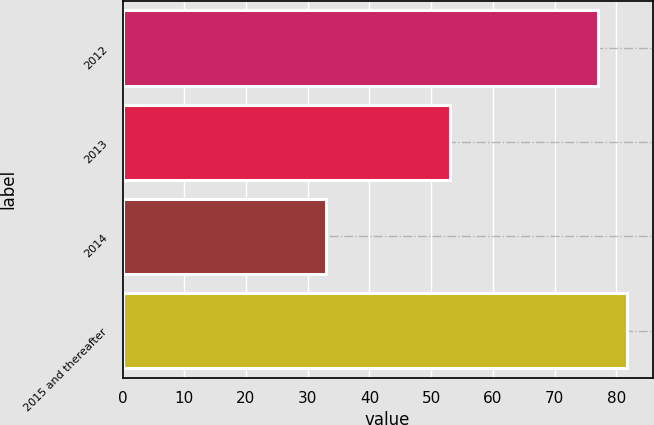Convert chart. <chart><loc_0><loc_0><loc_500><loc_500><bar_chart><fcel>2012<fcel>2013<fcel>2014<fcel>2015 and thereafter<nl><fcel>77<fcel>53<fcel>33<fcel>81.8<nl></chart> 